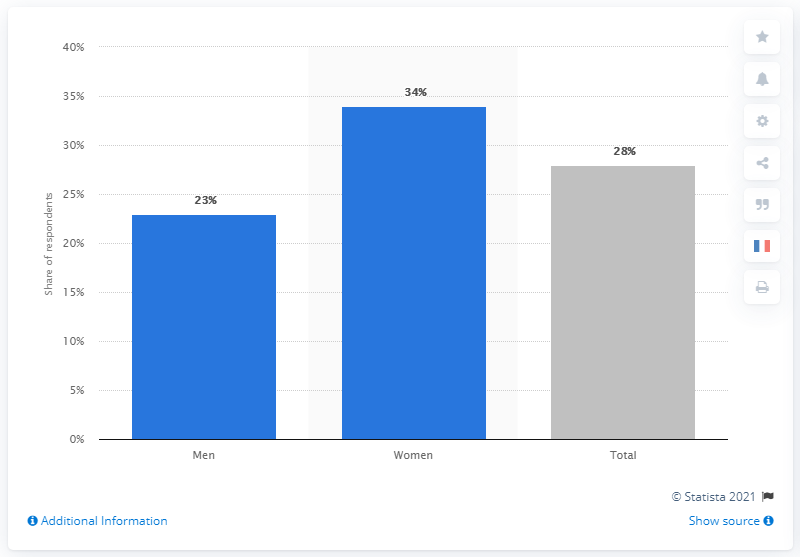Specify some key components in this picture. According to a survey conducted in Sweden in March 2020, 34% of women were worried about the Coronavirus. The percentage of men who were worried about Coronavirus was 23%. 